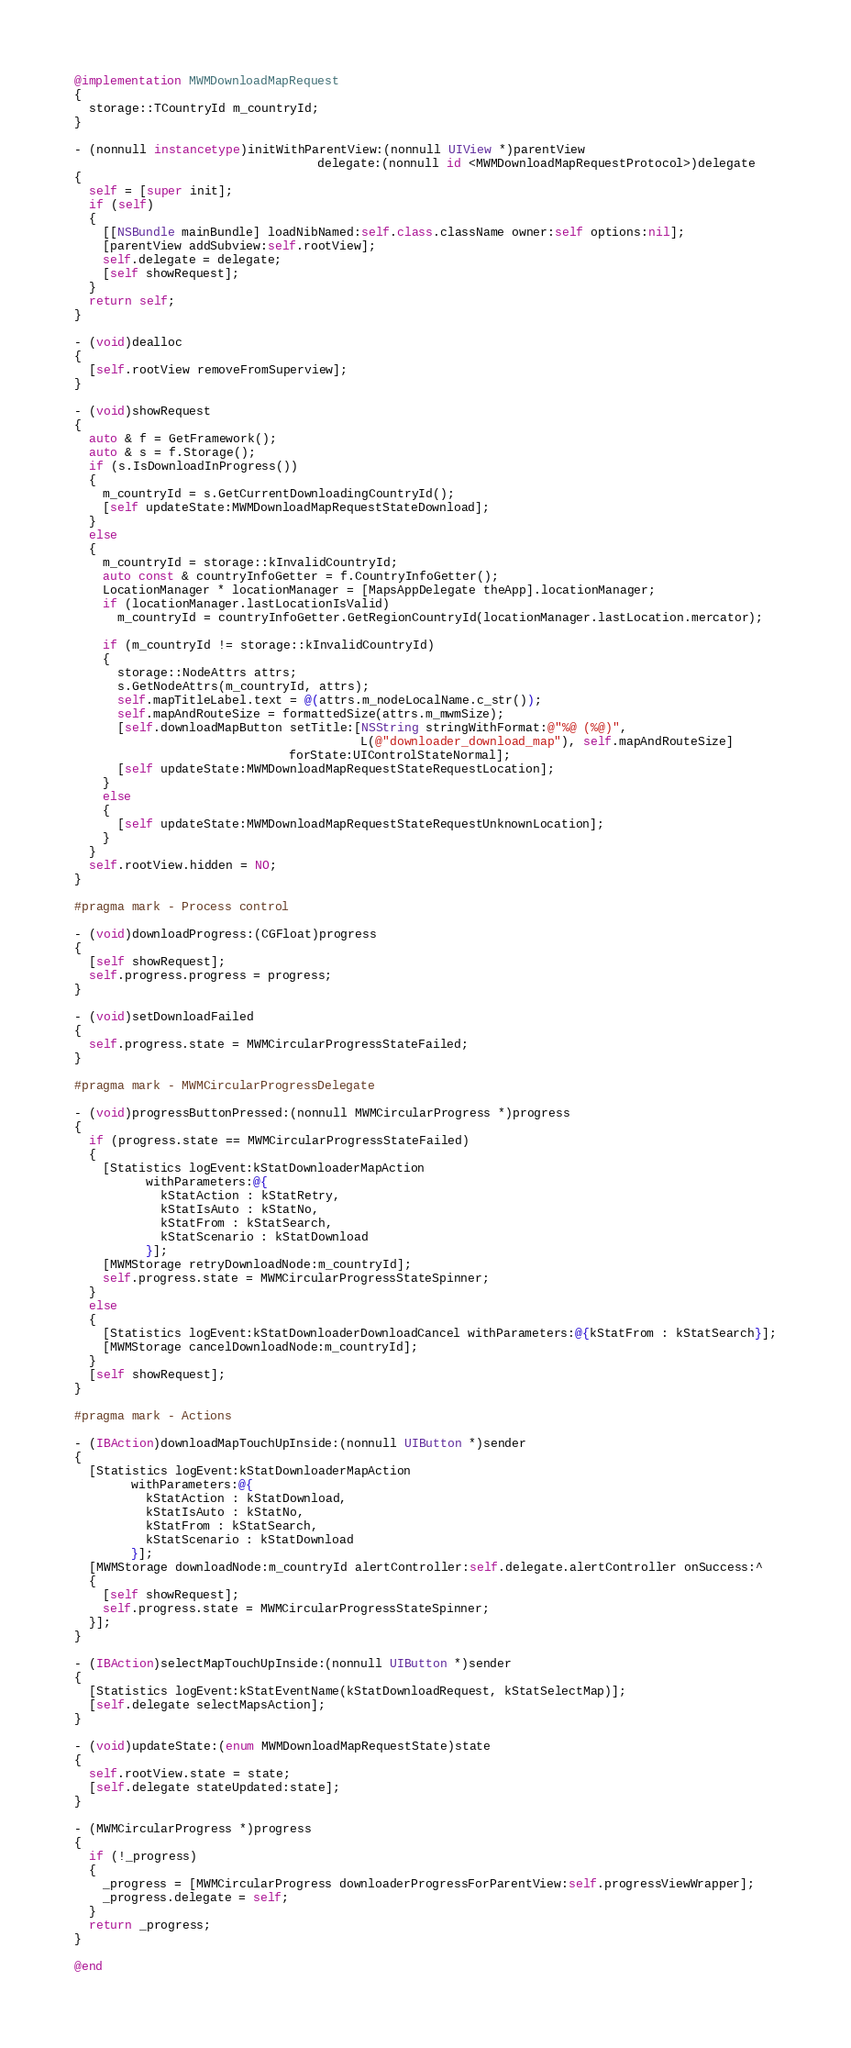Convert code to text. <code><loc_0><loc_0><loc_500><loc_500><_ObjectiveC_>
@implementation MWMDownloadMapRequest
{
  storage::TCountryId m_countryId;
}

- (nonnull instancetype)initWithParentView:(nonnull UIView *)parentView
                                  delegate:(nonnull id <MWMDownloadMapRequestProtocol>)delegate
{
  self = [super init];
  if (self)
  {
    [[NSBundle mainBundle] loadNibNamed:self.class.className owner:self options:nil];
    [parentView addSubview:self.rootView];
    self.delegate = delegate;
    [self showRequest];
  }
  return self;
}

- (void)dealloc
{
  [self.rootView removeFromSuperview];
}

- (void)showRequest
{
  auto & f = GetFramework();
  auto & s = f.Storage();
  if (s.IsDownloadInProgress())
  {
    m_countryId = s.GetCurrentDownloadingCountryId();
    [self updateState:MWMDownloadMapRequestStateDownload];
  }
  else
  {
    m_countryId = storage::kInvalidCountryId;
    auto const & countryInfoGetter = f.CountryInfoGetter();
    LocationManager * locationManager = [MapsAppDelegate theApp].locationManager;
    if (locationManager.lastLocationIsValid)
      m_countryId = countryInfoGetter.GetRegionCountryId(locationManager.lastLocation.mercator);

    if (m_countryId != storage::kInvalidCountryId)
    {
      storage::NodeAttrs attrs;
      s.GetNodeAttrs(m_countryId, attrs);
      self.mapTitleLabel.text = @(attrs.m_nodeLocalName.c_str());
      self.mapAndRouteSize = formattedSize(attrs.m_mwmSize);
      [self.downloadMapButton setTitle:[NSString stringWithFormat:@"%@ (%@)",
                                        L(@"downloader_download_map"), self.mapAndRouteSize]
                              forState:UIControlStateNormal];
      [self updateState:MWMDownloadMapRequestStateRequestLocation];
    }
    else
    {
      [self updateState:MWMDownloadMapRequestStateRequestUnknownLocation];
    }
  }
  self.rootView.hidden = NO;
}

#pragma mark - Process control

- (void)downloadProgress:(CGFloat)progress
{
  [self showRequest];
  self.progress.progress = progress;
}

- (void)setDownloadFailed
{
  self.progress.state = MWMCircularProgressStateFailed;
}

#pragma mark - MWMCircularProgressDelegate

- (void)progressButtonPressed:(nonnull MWMCircularProgress *)progress
{
  if (progress.state == MWMCircularProgressStateFailed)
  {
    [Statistics logEvent:kStatDownloaderMapAction
          withParameters:@{
            kStatAction : kStatRetry,
            kStatIsAuto : kStatNo,
            kStatFrom : kStatSearch,
            kStatScenario : kStatDownload
          }];
    [MWMStorage retryDownloadNode:m_countryId];
    self.progress.state = MWMCircularProgressStateSpinner;
  }
  else
  {
    [Statistics logEvent:kStatDownloaderDownloadCancel withParameters:@{kStatFrom : kStatSearch}];
    [MWMStorage cancelDownloadNode:m_countryId];
  }
  [self showRequest];
}

#pragma mark - Actions

- (IBAction)downloadMapTouchUpInside:(nonnull UIButton *)sender
{
  [Statistics logEvent:kStatDownloaderMapAction
        withParameters:@{
          kStatAction : kStatDownload,
          kStatIsAuto : kStatNo,
          kStatFrom : kStatSearch,
          kStatScenario : kStatDownload
        }];
  [MWMStorage downloadNode:m_countryId alertController:self.delegate.alertController onSuccess:^
  {
    [self showRequest];
    self.progress.state = MWMCircularProgressStateSpinner;
  }];
}

- (IBAction)selectMapTouchUpInside:(nonnull UIButton *)sender
{
  [Statistics logEvent:kStatEventName(kStatDownloadRequest, kStatSelectMap)];
  [self.delegate selectMapsAction];
}

- (void)updateState:(enum MWMDownloadMapRequestState)state
{
  self.rootView.state = state;
  [self.delegate stateUpdated:state];
}

- (MWMCircularProgress *)progress
{
  if (!_progress)
  {
    _progress = [MWMCircularProgress downloaderProgressForParentView:self.progressViewWrapper];
    _progress.delegate = self;
  }
  return _progress;
}

@end
</code> 